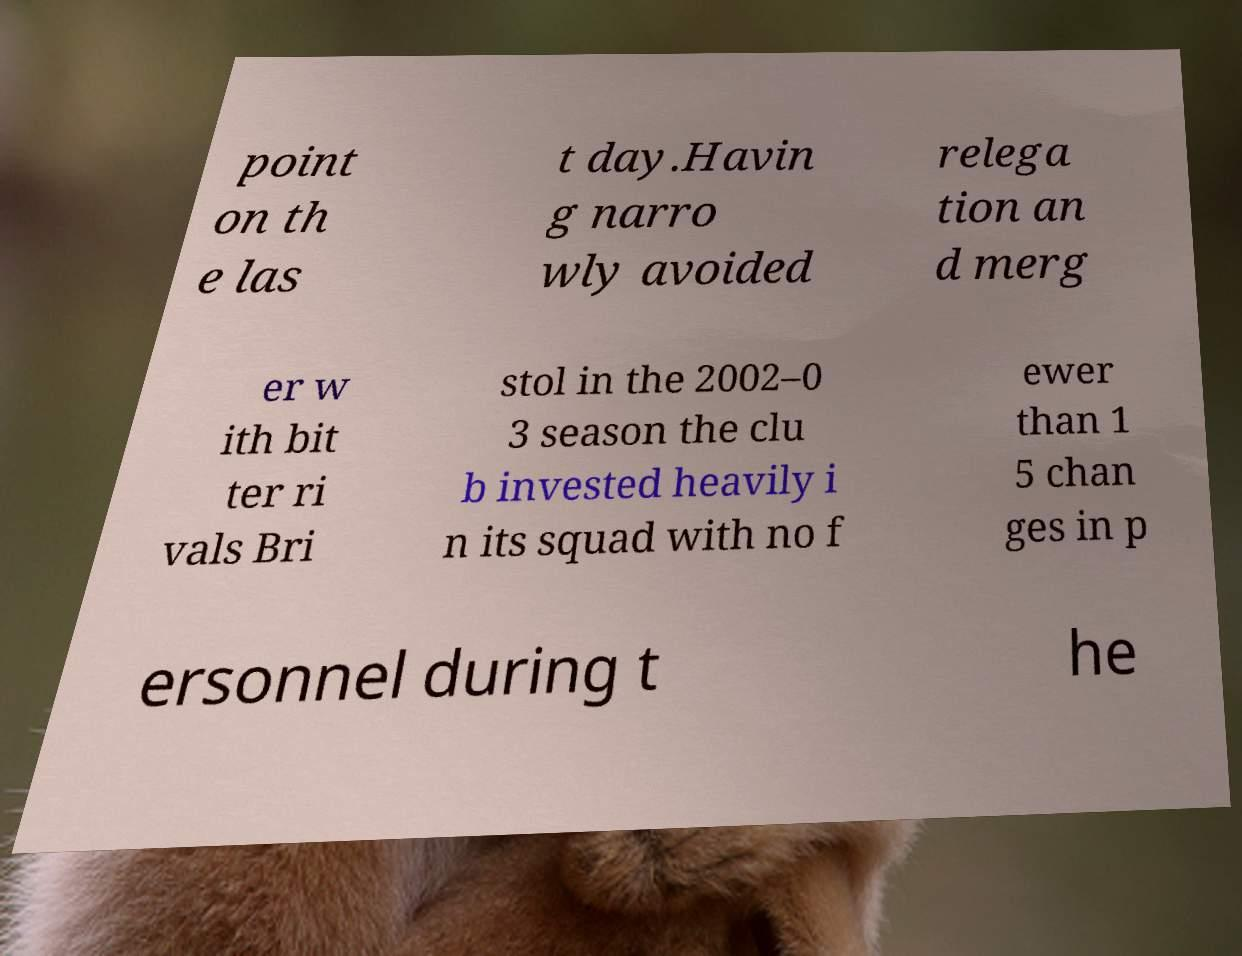Could you assist in decoding the text presented in this image and type it out clearly? point on th e las t day.Havin g narro wly avoided relega tion an d merg er w ith bit ter ri vals Bri stol in the 2002–0 3 season the clu b invested heavily i n its squad with no f ewer than 1 5 chan ges in p ersonnel during t he 